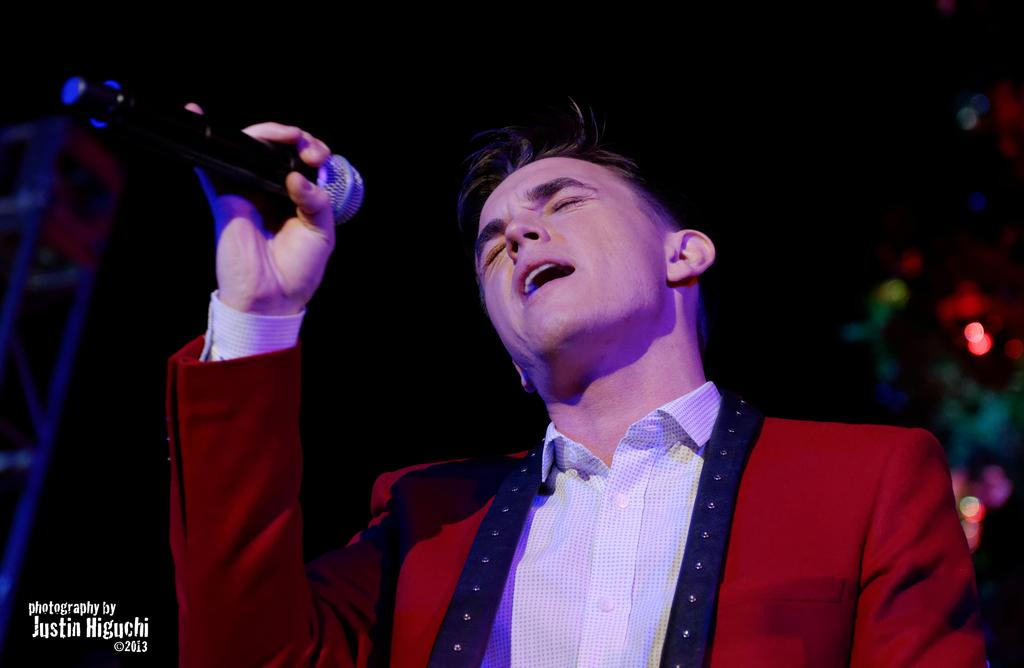What is the person in the image holding? The person is holding a microphone in the image. What can be seen on the left side of the image? There are metal rods on the left side of the image. Is there any text visible in the image? Yes, there is some text on the left bottom of the image. How would you describe the background of the image? The background is blurry. What type of floor can be seen in the image? There is no floor visible in the image; it is focused on the person holding the microphone and the surrounding elements. 